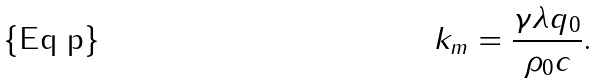<formula> <loc_0><loc_0><loc_500><loc_500>k _ { m } = \frac { \gamma \lambda q _ { 0 } } { \rho _ { 0 } c } .</formula> 